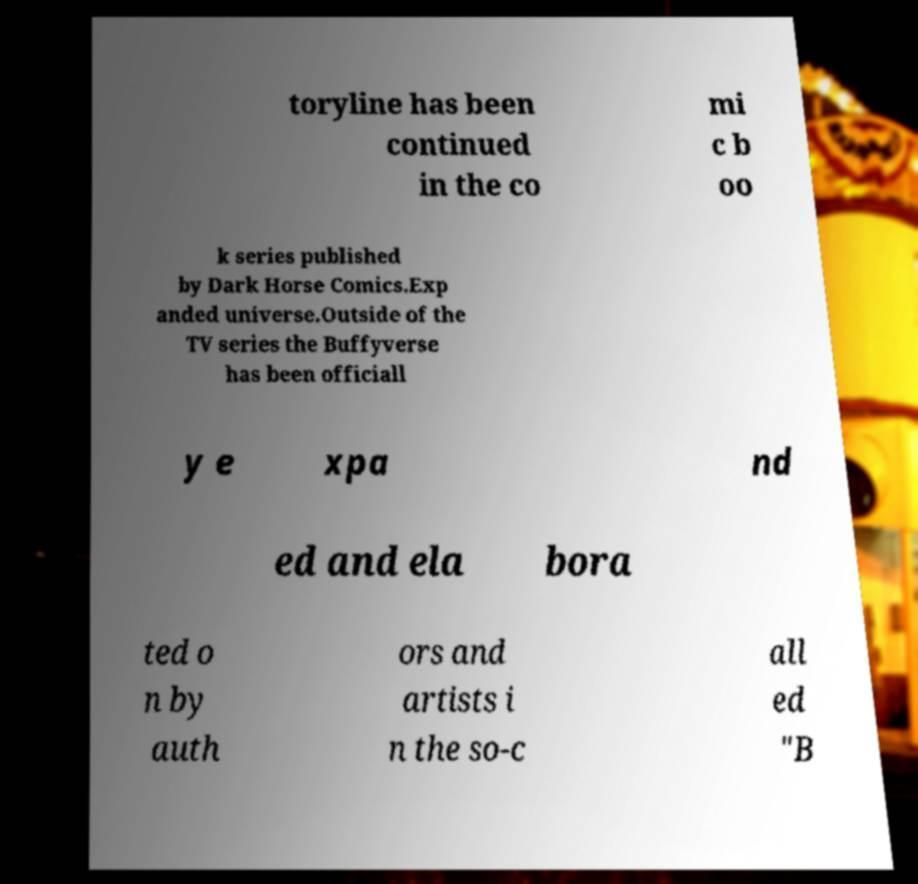Can you read and provide the text displayed in the image?This photo seems to have some interesting text. Can you extract and type it out for me? toryline has been continued in the co mi c b oo k series published by Dark Horse Comics.Exp anded universe.Outside of the TV series the Buffyverse has been officiall y e xpa nd ed and ela bora ted o n by auth ors and artists i n the so-c all ed "B 